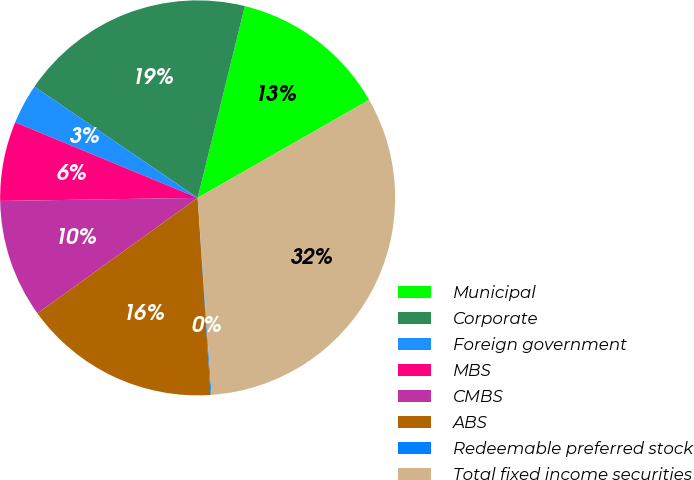Convert chart. <chart><loc_0><loc_0><loc_500><loc_500><pie_chart><fcel>Municipal<fcel>Corporate<fcel>Foreign government<fcel>MBS<fcel>CMBS<fcel>ABS<fcel>Redeemable preferred stock<fcel>Total fixed income securities<nl><fcel>12.9%<fcel>19.32%<fcel>3.28%<fcel>6.49%<fcel>9.69%<fcel>16.11%<fcel>0.07%<fcel>32.14%<nl></chart> 